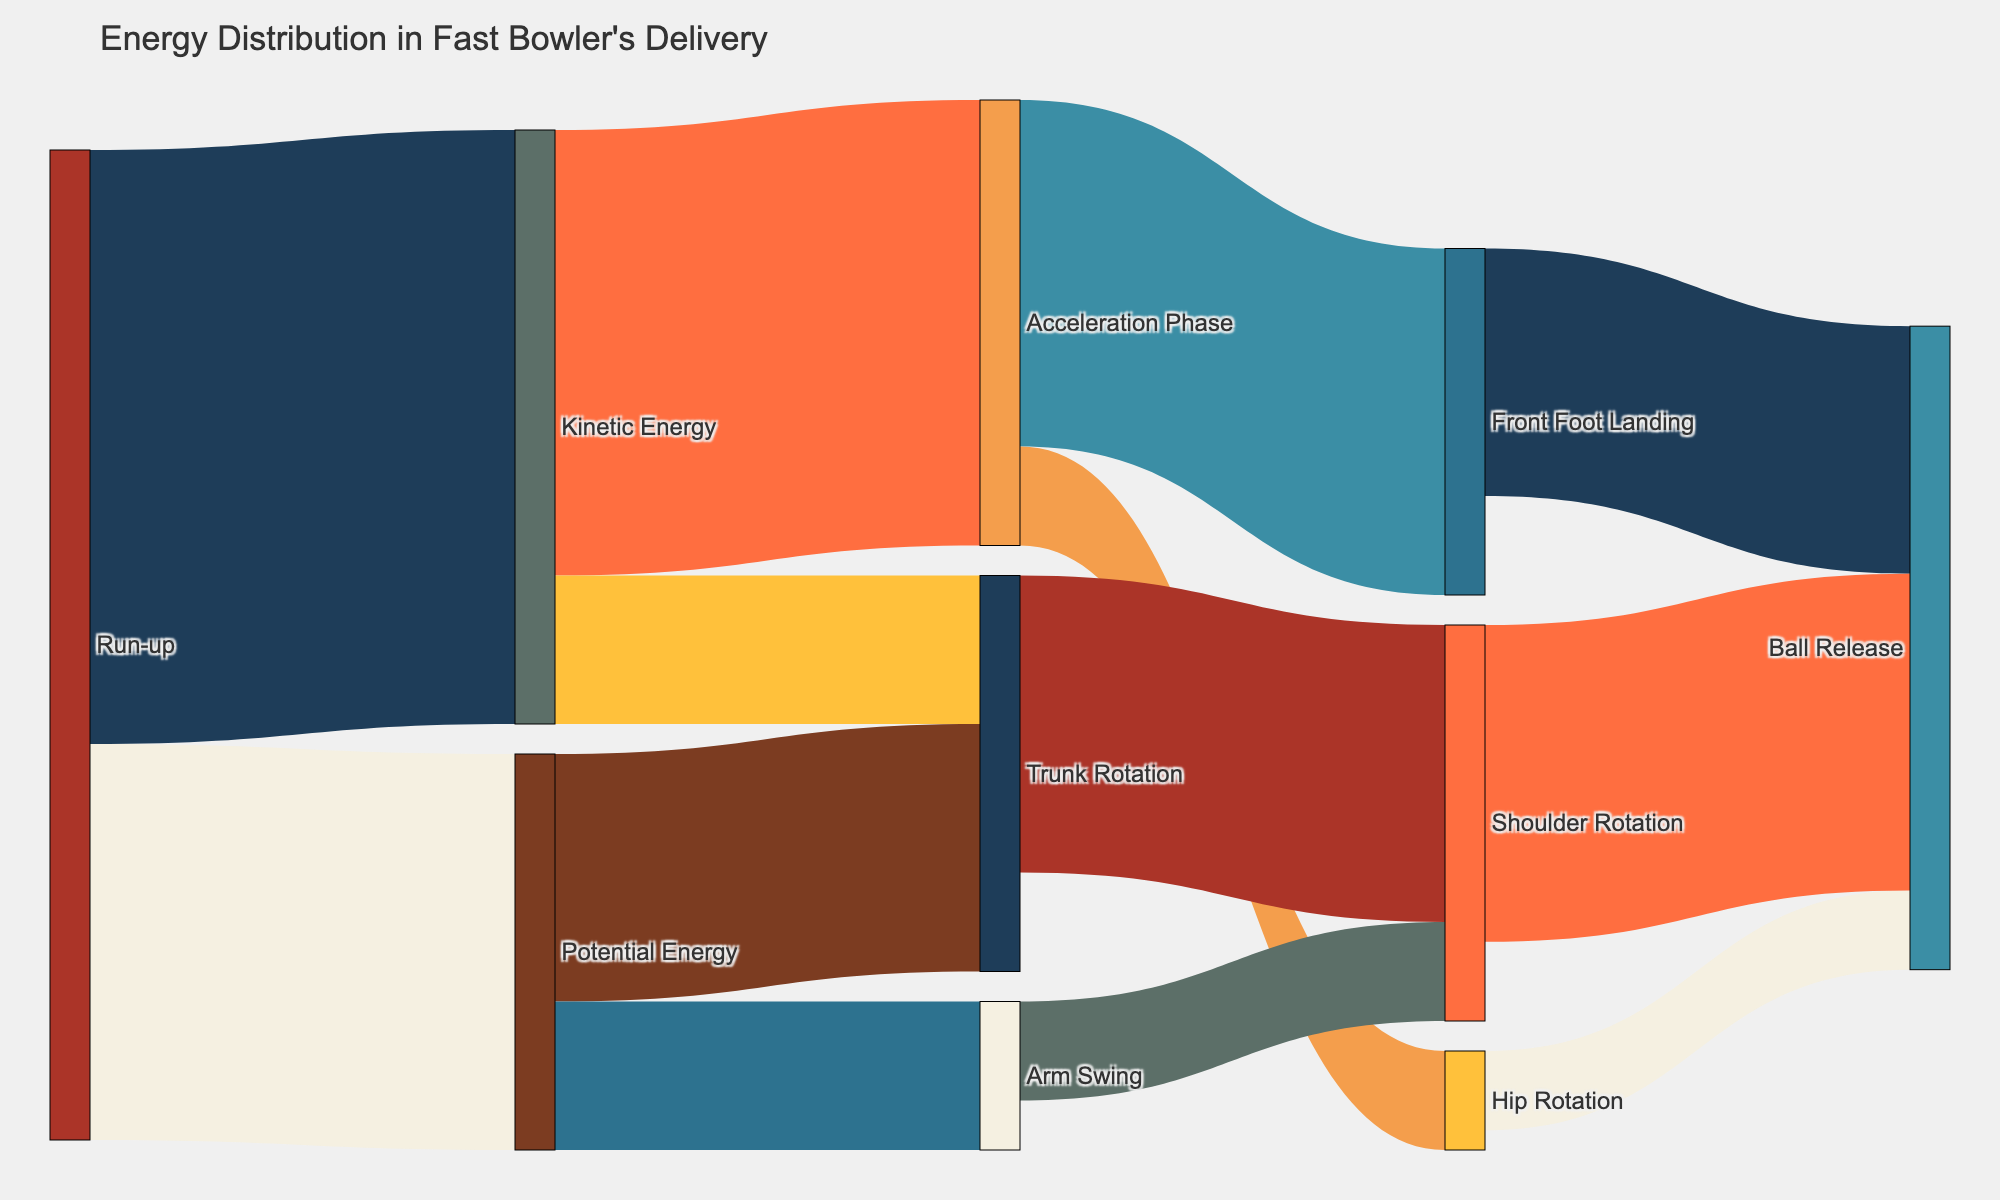What's the title of the figure? The title is displayed prominently at the top of the figure and provides an overview of what the diagram represents.
Answer: Energy Distribution in Fast Bowler's Delivery What type of energy is transferred from 'Run-up' to three different subsequent processes? We observe the arrows extending from 'Run-up'. They lead to 'Kinetic Energy' and 'Potential Energy', indicating these processes as it forks into subsequent processes.
Answer: Kinetic Energy and Potential Energy How much total energy from 'Run-up' is converted into 'Kinetic Energy' and 'Potential Energy'? The values are indicated by the width of the arrows from 'Run-up' to 'Kinetic Energy' and 'Potential Energy'. Adding these values gives us the total energy.
Answer: 100 How much energy does 'Trunk Rotation' receive in total from 'Kinetic Energy' and 'Potential Energy'? We look at the arrows converging into 'Trunk Rotation'. By adding the energy values from both 'Kinetic Energy' and 'Potential Energy', we obtain the total.
Answer: 40 Which process receives the highest amount of energy from 'Shoulder Rotation' in the ball release phase? By inspecting the arrows originating from 'Shoulder Rotation' and leading to the 'Ball Release' phase, we can determine which has the widest arrow indicating the highest energy value.
Answer: Ball Release (32) Compare the amount of energy converted from 'Acceleration Phase' to 'Front Foot Landing' and 'Hip Rotation'. Which one is greater? Examine the width of the arrows going from 'Acceleration Phase' to both 'Front Foot Landing' and 'Hip Rotation'. The wider arrow represents the greater value.
Answer: Front Foot Landing What is the total energy involved in the 'Ball Release' phase from all contributing sources? We add the energy values from all processes leading into 'Ball Release', including 'Front Foot Landing', 'Hip Rotation', and 'Shoulder Rotation'.
Answer: 65 Which process receives more energy from 'Kinetic Energy': 'Acceleration Phase' or 'Trunk Rotation'? By comparing the widths of the arrows extending from 'Kinetic Energy' to 'Acceleration Phase' and 'Trunk Rotation', we identify the process receiving more energy.
Answer: Acceleration Phase Determine the combined energy input of 'Run-up' to 'Kinetic Energy' and 'Potential Energy', and describe its subsequent distribution to processes. Begin by summing the energy contributions from 'Run-up' to 'Kinetic Energy' and 'Potential Energy'. Follow by delineating the arrows that indicate further distribution into secondary processes from both energy types.
Answer: 100 total; 45 to Acceleration Phase, 15 to Trunk Rotation from Kinetic; 25 to Trunk Rotation, 15 to Arm Swing from Potential 